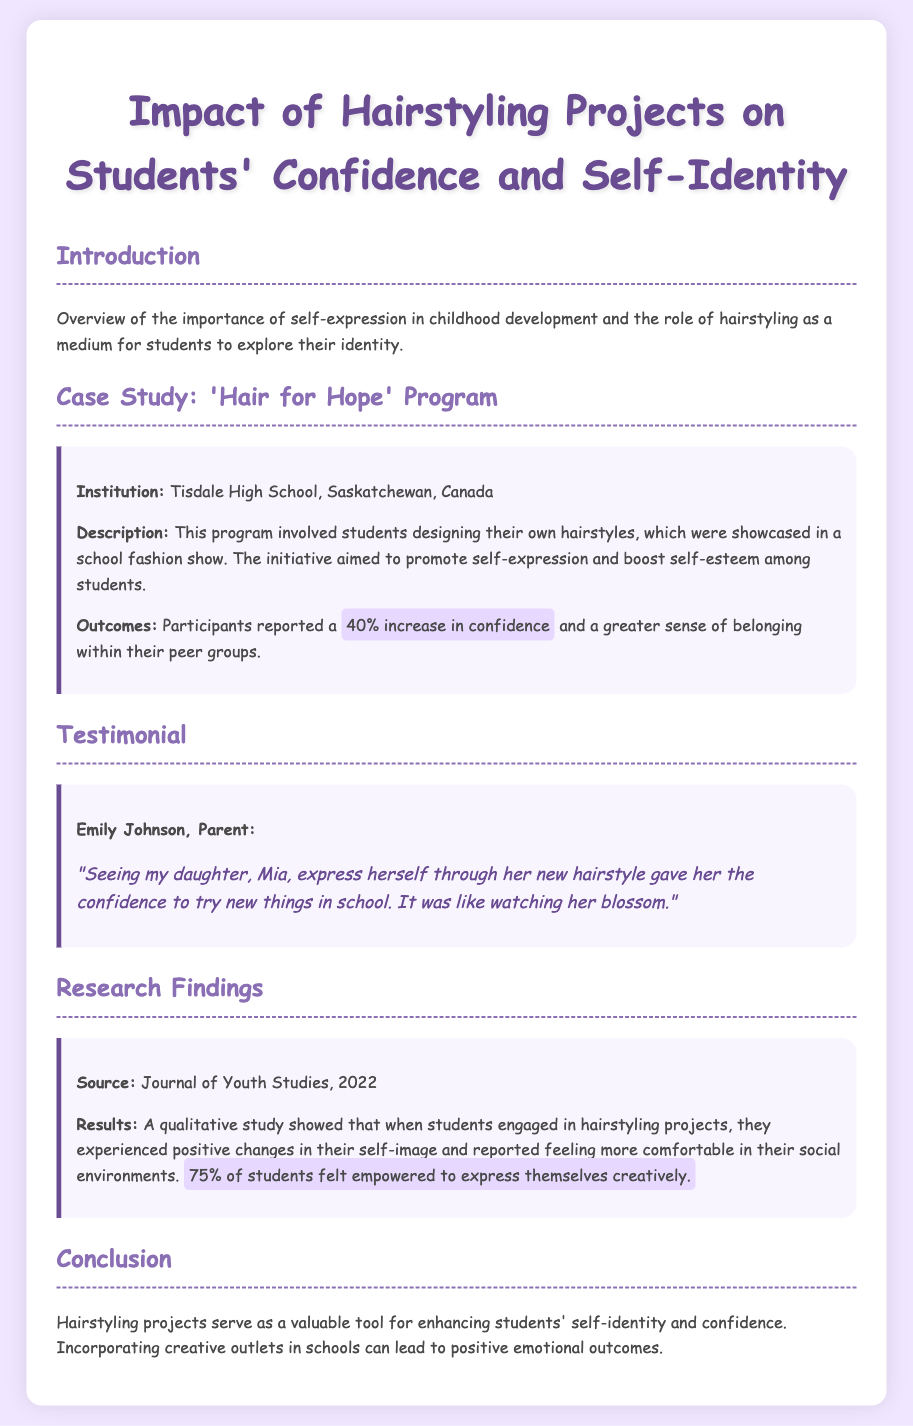What is the name of the program highlighted in the case study? The program that is highlighted is aimed at promoting self-expression through hairstyling projects among students.
Answer: Hair for Hope What percentage of participants reported an increase in confidence? This figure is found in the case study section and indicates how effective the program was for students.
Answer: 40% Who provided the testimonial about her daughter? The document includes a testimonial section where a parent shares her feelings about the impact of the hairstyling project on her child.
Answer: Emily Johnson What is the source of the research findings? This information can be found in the research findings part, which provides credibility to the reported outcomes.
Answer: Journal of Youth Studies, 2022 How many students felt empowered to express themselves creatively? This figure reflects a significant outcome reported in the research findings, highlighting the overall impact of the project.
Answer: 75% 